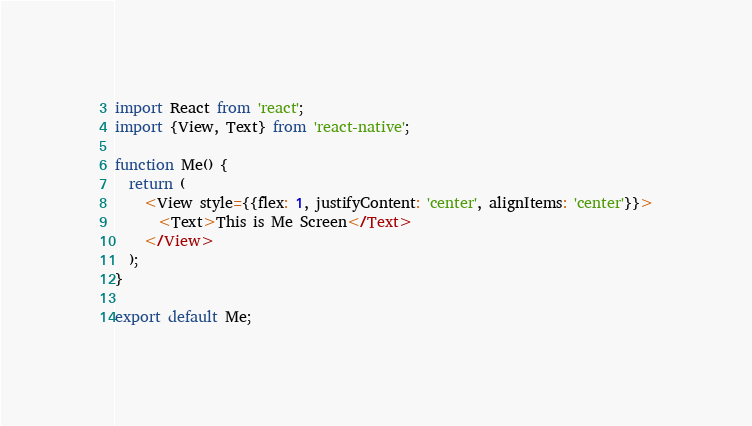Convert code to text. <code><loc_0><loc_0><loc_500><loc_500><_JavaScript_>import React from 'react';
import {View, Text} from 'react-native';

function Me() {
  return (
    <View style={{flex: 1, justifyContent: 'center', alignItems: 'center'}}>
      <Text>This is Me Screen</Text>
    </View>
  );
}

export default Me;
</code> 